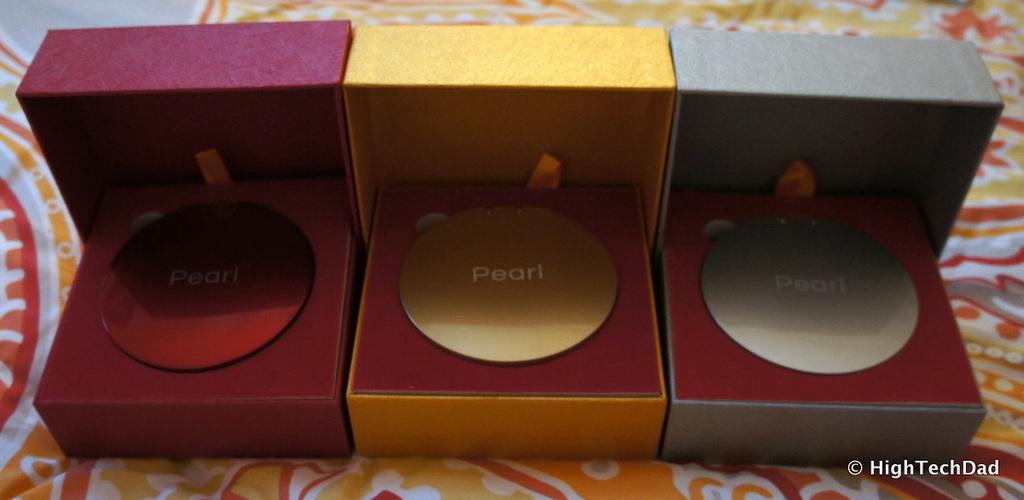What is the brand on this item?
Make the answer very short. Pearl. 